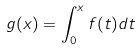Convert formula to latex. <formula><loc_0><loc_0><loc_500><loc_500>g ( x ) = \int _ { 0 } ^ { x } f ( t ) d t</formula> 